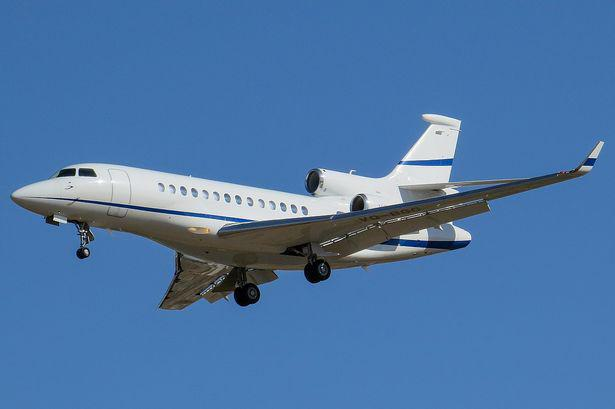Can you tell the altitude at which the airplane is flying? While it's difficult to determine the exact altitude from an image, the airplane appears to be on its landing approach, suggesting it's at a relatively low altitude, likely a few thousand feet above ground level. 